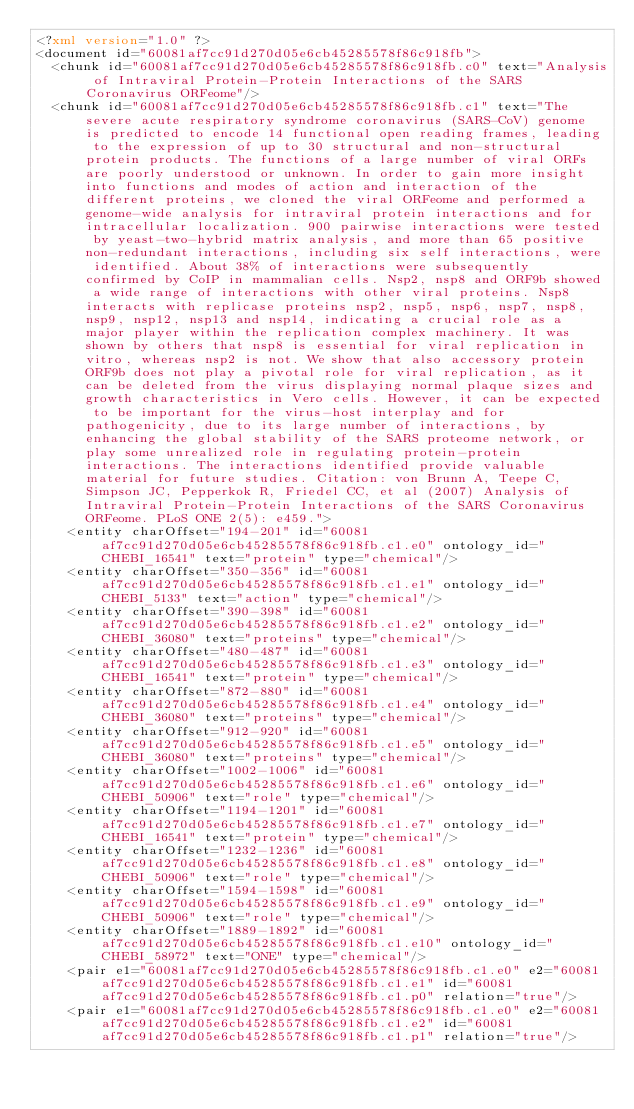<code> <loc_0><loc_0><loc_500><loc_500><_XML_><?xml version="1.0" ?>
<document id="60081af7cc91d270d05e6cb45285578f86c918fb">
  <chunk id="60081af7cc91d270d05e6cb45285578f86c918fb.c0" text="Analysis of Intraviral Protein-Protein Interactions of the SARS Coronavirus ORFeome"/>
  <chunk id="60081af7cc91d270d05e6cb45285578f86c918fb.c1" text="The severe acute respiratory syndrome coronavirus (SARS-CoV) genome is predicted to encode 14 functional open reading frames, leading to the expression of up to 30 structural and non-structural protein products. The functions of a large number of viral ORFs are poorly understood or unknown. In order to gain more insight into functions and modes of action and interaction of the different proteins, we cloned the viral ORFeome and performed a genome-wide analysis for intraviral protein interactions and for intracellular localization. 900 pairwise interactions were tested by yeast-two-hybrid matrix analysis, and more than 65 positive non-redundant interactions, including six self interactions, were identified. About 38% of interactions were subsequently confirmed by CoIP in mammalian cells. Nsp2, nsp8 and ORF9b showed a wide range of interactions with other viral proteins. Nsp8 interacts with replicase proteins nsp2, nsp5, nsp6, nsp7, nsp8, nsp9, nsp12, nsp13 and nsp14, indicating a crucial role as a major player within the replication complex machinery. It was shown by others that nsp8 is essential for viral replication in vitro, whereas nsp2 is not. We show that also accessory protein ORF9b does not play a pivotal role for viral replication, as it can be deleted from the virus displaying normal plaque sizes and growth characteristics in Vero cells. However, it can be expected to be important for the virus-host interplay and for pathogenicity, due to its large number of interactions, by enhancing the global stability of the SARS proteome network, or play some unrealized role in regulating protein-protein interactions. The interactions identified provide valuable material for future studies. Citation: von Brunn A, Teepe C, Simpson JC, Pepperkok R, Friedel CC, et al (2007) Analysis of Intraviral Protein-Protein Interactions of the SARS Coronavirus ORFeome. PLoS ONE 2(5): e459.">
    <entity charOffset="194-201" id="60081af7cc91d270d05e6cb45285578f86c918fb.c1.e0" ontology_id="CHEBI_16541" text="protein" type="chemical"/>
    <entity charOffset="350-356" id="60081af7cc91d270d05e6cb45285578f86c918fb.c1.e1" ontology_id="CHEBI_5133" text="action" type="chemical"/>
    <entity charOffset="390-398" id="60081af7cc91d270d05e6cb45285578f86c918fb.c1.e2" ontology_id="CHEBI_36080" text="proteins" type="chemical"/>
    <entity charOffset="480-487" id="60081af7cc91d270d05e6cb45285578f86c918fb.c1.e3" ontology_id="CHEBI_16541" text="protein" type="chemical"/>
    <entity charOffset="872-880" id="60081af7cc91d270d05e6cb45285578f86c918fb.c1.e4" ontology_id="CHEBI_36080" text="proteins" type="chemical"/>
    <entity charOffset="912-920" id="60081af7cc91d270d05e6cb45285578f86c918fb.c1.e5" ontology_id="CHEBI_36080" text="proteins" type="chemical"/>
    <entity charOffset="1002-1006" id="60081af7cc91d270d05e6cb45285578f86c918fb.c1.e6" ontology_id="CHEBI_50906" text="role" type="chemical"/>
    <entity charOffset="1194-1201" id="60081af7cc91d270d05e6cb45285578f86c918fb.c1.e7" ontology_id="CHEBI_16541" text="protein" type="chemical"/>
    <entity charOffset="1232-1236" id="60081af7cc91d270d05e6cb45285578f86c918fb.c1.e8" ontology_id="CHEBI_50906" text="role" type="chemical"/>
    <entity charOffset="1594-1598" id="60081af7cc91d270d05e6cb45285578f86c918fb.c1.e9" ontology_id="CHEBI_50906" text="role" type="chemical"/>
    <entity charOffset="1889-1892" id="60081af7cc91d270d05e6cb45285578f86c918fb.c1.e10" ontology_id="CHEBI_58972" text="ONE" type="chemical"/>
    <pair e1="60081af7cc91d270d05e6cb45285578f86c918fb.c1.e0" e2="60081af7cc91d270d05e6cb45285578f86c918fb.c1.e1" id="60081af7cc91d270d05e6cb45285578f86c918fb.c1.p0" relation="true"/>
    <pair e1="60081af7cc91d270d05e6cb45285578f86c918fb.c1.e0" e2="60081af7cc91d270d05e6cb45285578f86c918fb.c1.e2" id="60081af7cc91d270d05e6cb45285578f86c918fb.c1.p1" relation="true"/></code> 